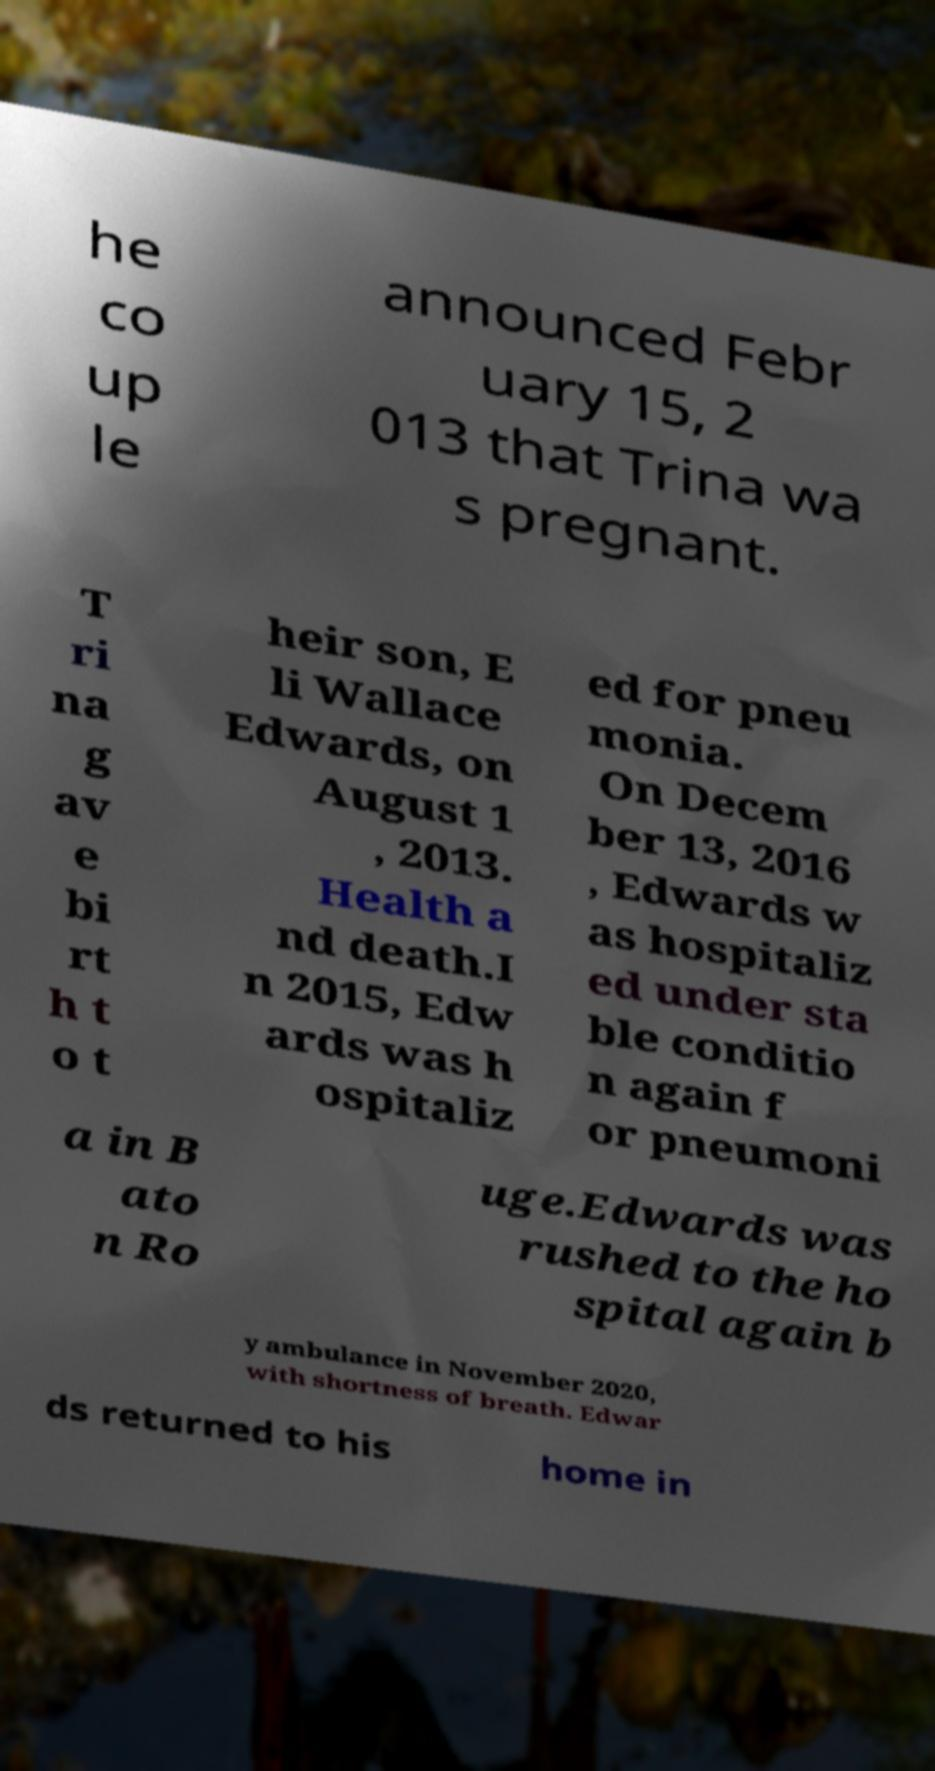Please read and relay the text visible in this image. What does it say? he co up le announced Febr uary 15, 2 013 that Trina wa s pregnant. T ri na g av e bi rt h t o t heir son, E li Wallace Edwards, on August 1 , 2013. Health a nd death.I n 2015, Edw ards was h ospitaliz ed for pneu monia. On Decem ber 13, 2016 , Edwards w as hospitaliz ed under sta ble conditio n again f or pneumoni a in B ato n Ro uge.Edwards was rushed to the ho spital again b y ambulance in November 2020, with shortness of breath. Edwar ds returned to his home in 